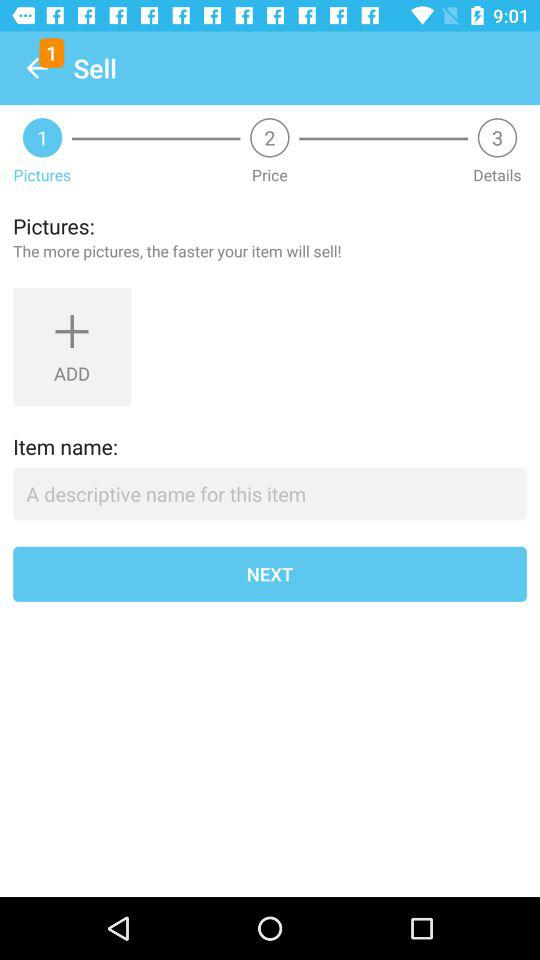What's the label of the first step? The label of the first step is "Pictures". 